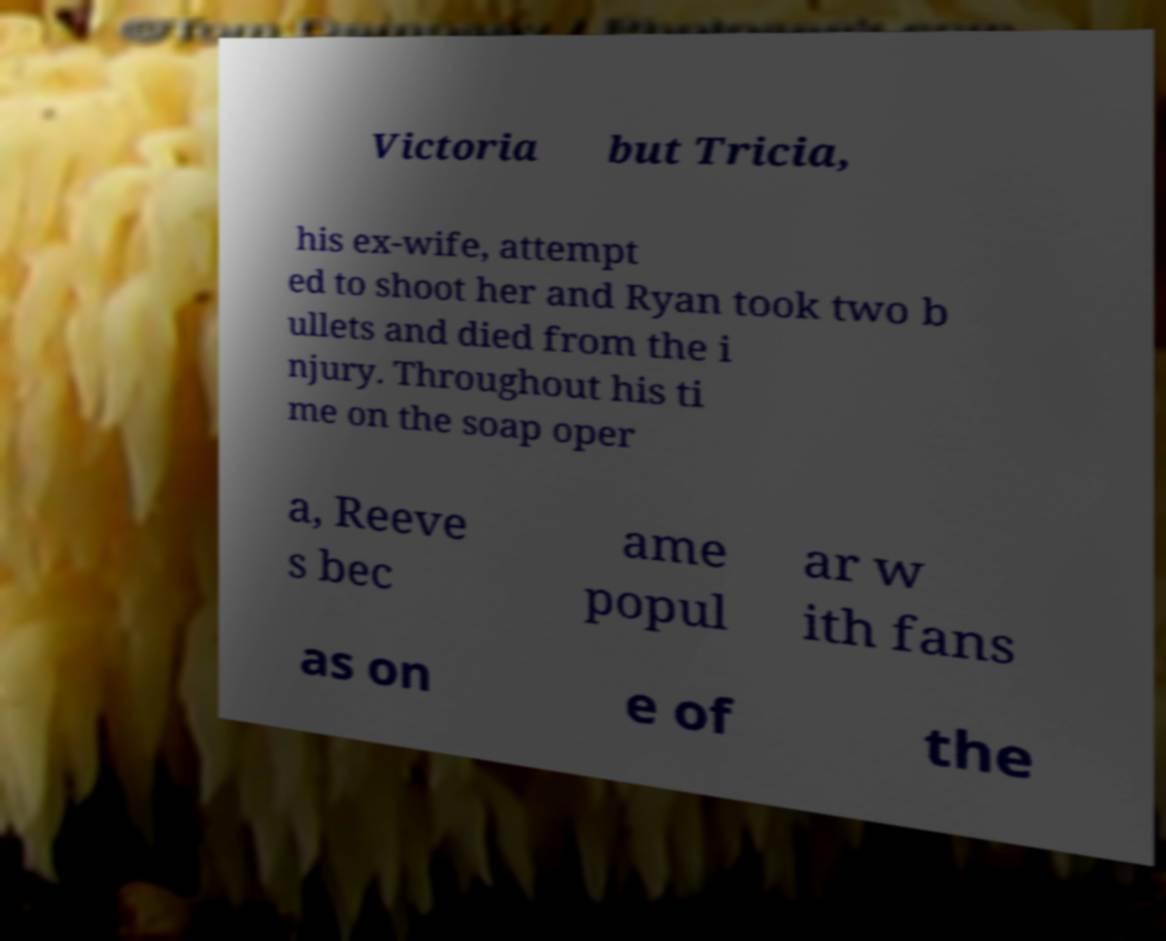There's text embedded in this image that I need extracted. Can you transcribe it verbatim? Victoria but Tricia, his ex-wife, attempt ed to shoot her and Ryan took two b ullets and died from the i njury. Throughout his ti me on the soap oper a, Reeve s bec ame popul ar w ith fans as on e of the 